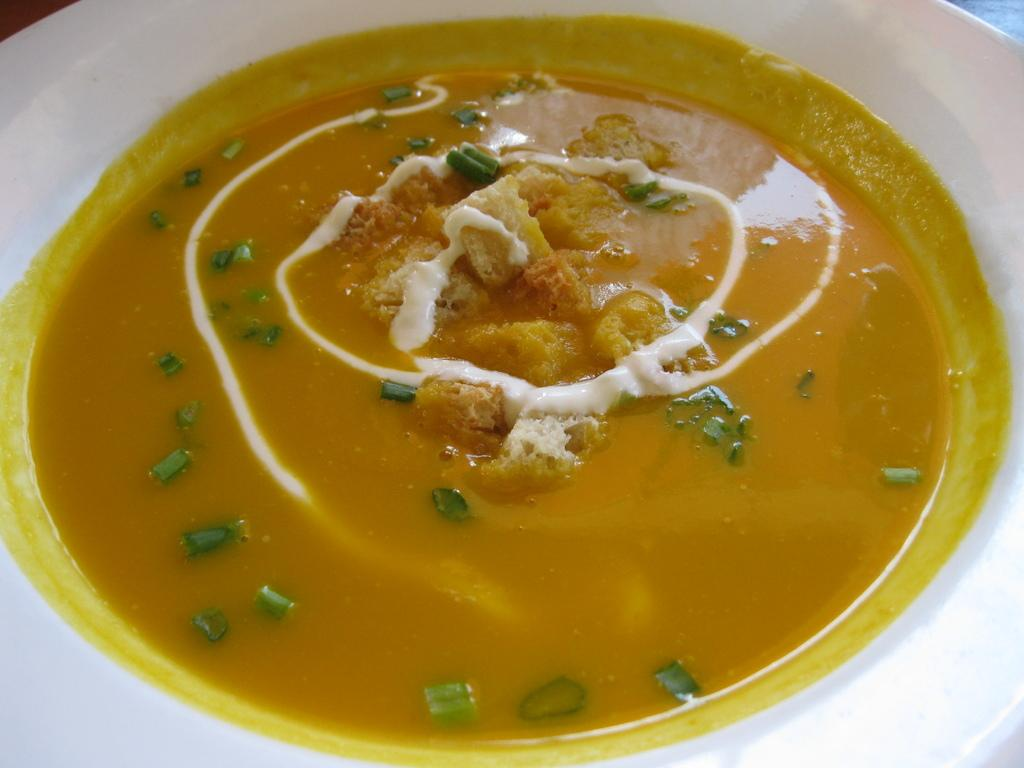What is in the bowl that is visible in the image? There is a bowl in the image. What color is the bowl? The bowl is white in color. What is inside the bowl? There is soup in the bowl. What color is the soup? The soup is yellow in color. How many points does the disgusting wall have in the image? There is no mention of a wall, let alone a disgusting one, in the provided facts. Therefore, it is impossible to answer this question based on the information given. 